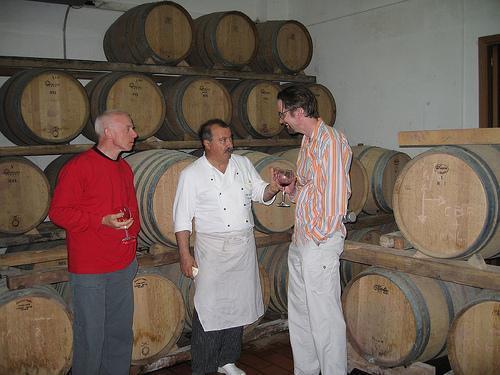How many people are there?
Give a very brief answer. 3. 